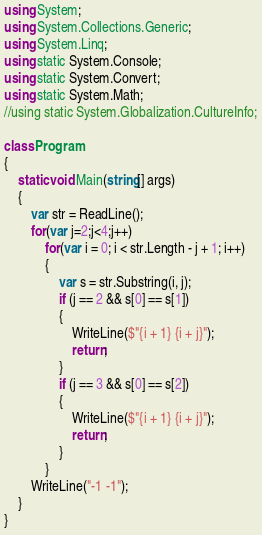Convert code to text. <code><loc_0><loc_0><loc_500><loc_500><_C#_>using System;
using System.Collections.Generic;
using System.Linq;
using static System.Console;
using static System.Convert;
using static System.Math;
//using static System.Globalization.CultureInfo;

class Program
{
    static void Main(string[] args)
    {
        var str = ReadLine();
        for(var j=2;j<4;j++)
            for(var i = 0; i < str.Length - j + 1; i++)
            {
                var s = str.Substring(i, j);
                if (j == 2 && s[0] == s[1])
                {
                    WriteLine($"{i + 1} {i + j}");
                    return;
                }
                if (j == 3 && s[0] == s[2])
                {
                    WriteLine($"{i + 1} {i + j}");
                    return;
                }
            }
        WriteLine("-1 -1");
    }
}
</code> 